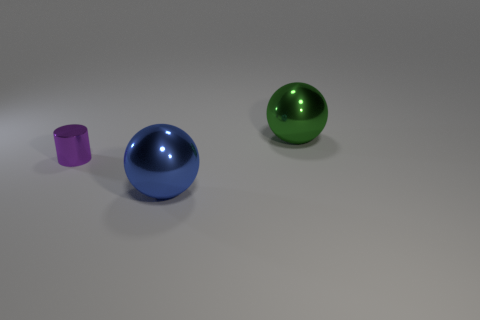How many purple things have the same material as the large green ball?
Provide a short and direct response. 1. What number of things are big gray rubber objects or objects in front of the small purple thing?
Provide a short and direct response. 1. There is a sphere on the left side of the big metallic object that is behind the sphere left of the green thing; what is its color?
Give a very brief answer. Blue. There is a ball in front of the small purple shiny cylinder; how big is it?
Your answer should be compact. Large. How many small things are either blue metal cubes or purple shiny objects?
Make the answer very short. 1. There is a thing that is both behind the large blue ball and left of the large green object; what is its color?
Provide a succinct answer. Purple. Is there a large green object that has the same shape as the small purple metallic object?
Offer a very short reply. No. What is the blue ball made of?
Your answer should be very brief. Metal. There is a blue metallic thing; are there any large balls in front of it?
Keep it short and to the point. No. Do the blue metallic object and the small shiny thing have the same shape?
Keep it short and to the point. No. 